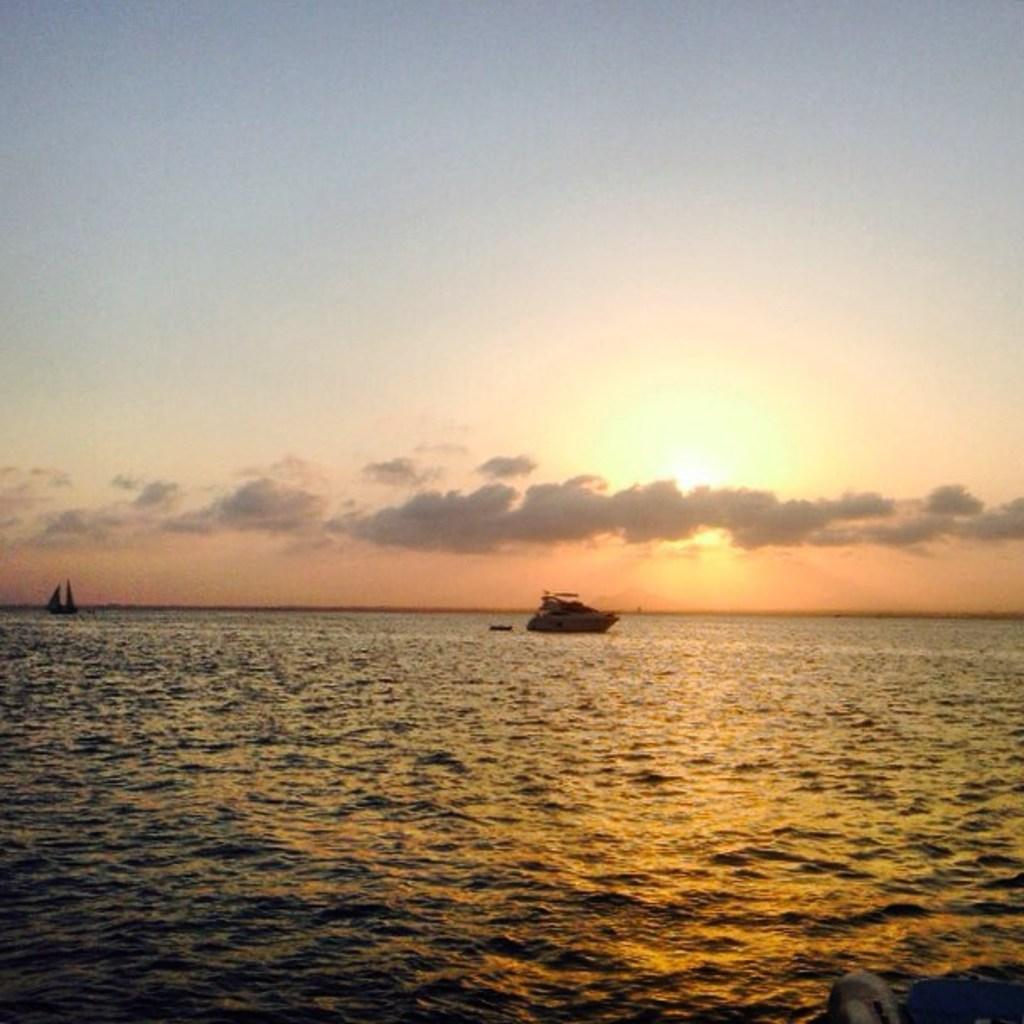Where was the picture taken? The picture was clicked outside. What can be seen in the water body in the image? There are boats in the water body. What is visible in the background of the image? The sky with clouds is visible in the background. Can you describe the celestial body visible in the image? The sun is visible in the image. What type of apple is being used as bait for the fish in the image? There is no apple or fishing activity present in the image; it features boats in a water body with the sky and sun visible in the background. 